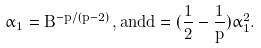<formula> <loc_0><loc_0><loc_500><loc_500>\alpha _ { 1 } = B ^ { - p / ( p - 2 ) } \, , a n d d = ( \frac { 1 } { 2 } - \frac { 1 } { p } ) \alpha _ { 1 } ^ { 2 } .</formula> 